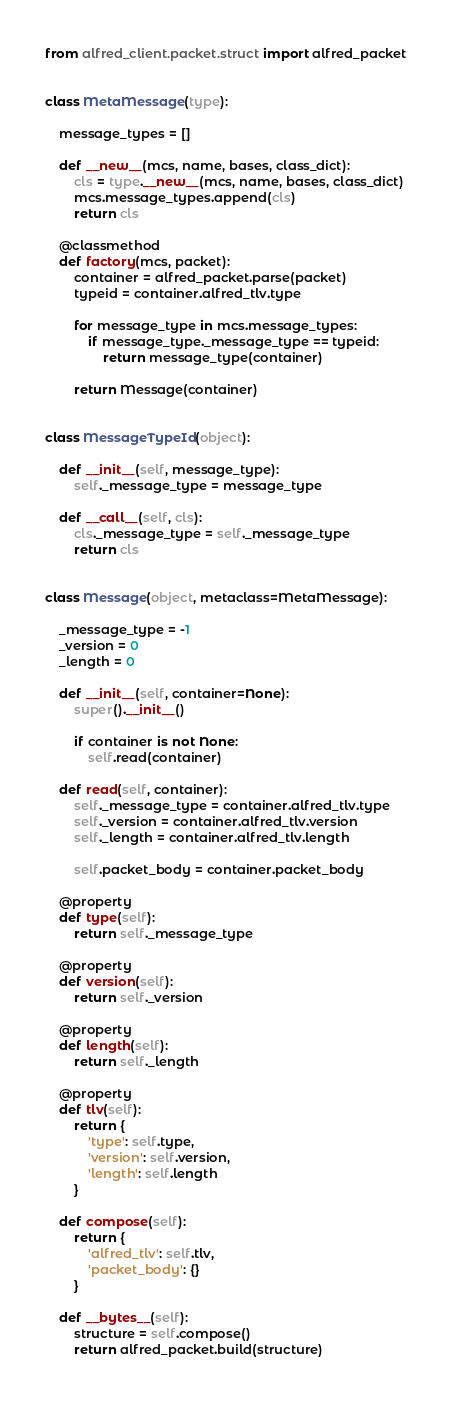Convert code to text. <code><loc_0><loc_0><loc_500><loc_500><_Python_>from alfred_client.packet.struct import alfred_packet


class MetaMessage(type):

    message_types = []

    def __new__(mcs, name, bases, class_dict):
        cls = type.__new__(mcs, name, bases, class_dict)
        mcs.message_types.append(cls)
        return cls

    @classmethod
    def factory(mcs, packet):
        container = alfred_packet.parse(packet)
        typeid = container.alfred_tlv.type

        for message_type in mcs.message_types:
            if message_type._message_type == typeid:
                return message_type(container)

        return Message(container)


class MessageTypeId(object):

    def __init__(self, message_type):
        self._message_type = message_type

    def __call__(self, cls):
        cls._message_type = self._message_type
        return cls


class Message(object, metaclass=MetaMessage):

    _message_type = -1
    _version = 0
    _length = 0

    def __init__(self, container=None):
        super().__init__()

        if container is not None:
            self.read(container)

    def read(self, container):
        self._message_type = container.alfred_tlv.type
        self._version = container.alfred_tlv.version
        self._length = container.alfred_tlv.length

        self.packet_body = container.packet_body

    @property
    def type(self):
        return self._message_type

    @property
    def version(self):
        return self._version

    @property
    def length(self):
        return self._length

    @property
    def tlv(self):
        return {
            'type': self.type,
            'version': self.version,
            'length': self.length
        }

    def compose(self):
        return {
            'alfred_tlv': self.tlv,
            'packet_body': {}
        }

    def __bytes__(self):
        structure = self.compose()
        return alfred_packet.build(structure)
</code> 